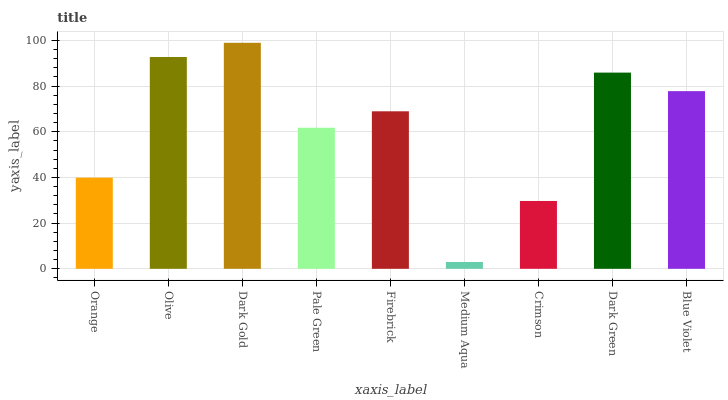Is Medium Aqua the minimum?
Answer yes or no. Yes. Is Dark Gold the maximum?
Answer yes or no. Yes. Is Olive the minimum?
Answer yes or no. No. Is Olive the maximum?
Answer yes or no. No. Is Olive greater than Orange?
Answer yes or no. Yes. Is Orange less than Olive?
Answer yes or no. Yes. Is Orange greater than Olive?
Answer yes or no. No. Is Olive less than Orange?
Answer yes or no. No. Is Firebrick the high median?
Answer yes or no. Yes. Is Firebrick the low median?
Answer yes or no. Yes. Is Medium Aqua the high median?
Answer yes or no. No. Is Orange the low median?
Answer yes or no. No. 